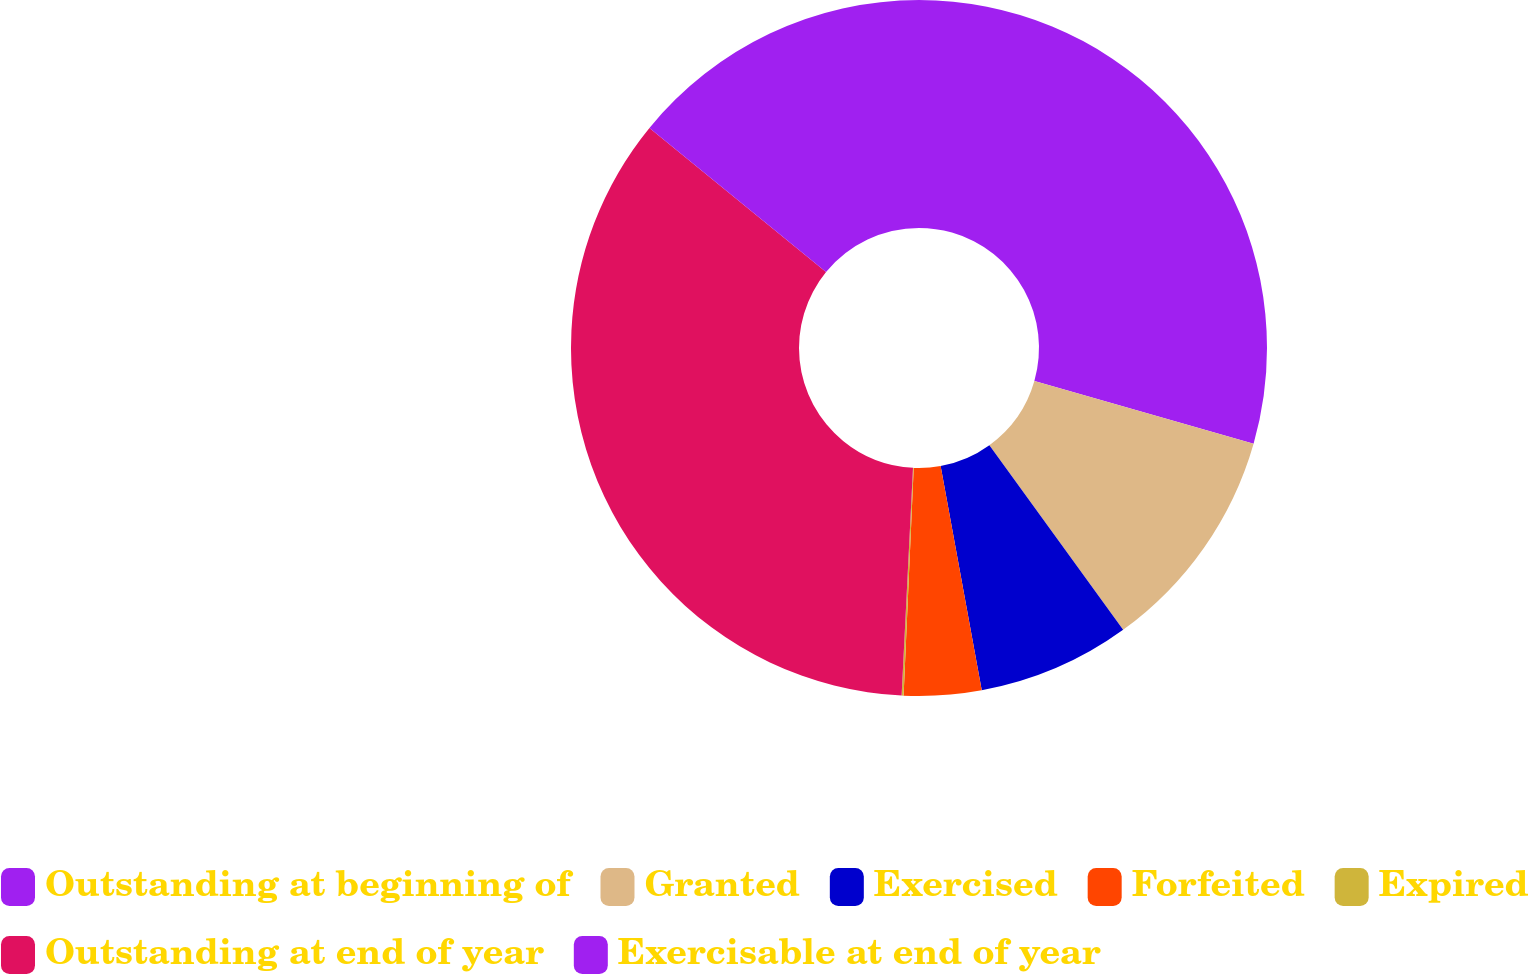Convert chart. <chart><loc_0><loc_0><loc_500><loc_500><pie_chart><fcel>Outstanding at beginning of<fcel>Granted<fcel>Exercised<fcel>Forfeited<fcel>Expired<fcel>Outstanding at end of year<fcel>Exercisable at end of year<nl><fcel>29.43%<fcel>10.59%<fcel>7.09%<fcel>3.59%<fcel>0.09%<fcel>35.1%<fcel>14.1%<nl></chart> 